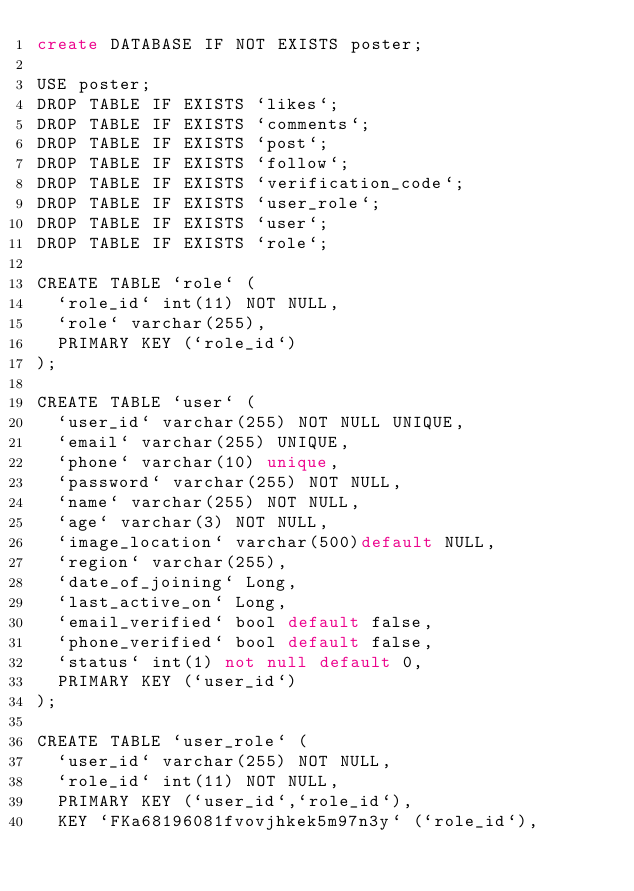<code> <loc_0><loc_0><loc_500><loc_500><_SQL_>create DATABASE IF NOT EXISTS poster;

USE poster;
DROP TABLE IF EXISTS `likes`;
DROP TABLE IF EXISTS `comments`;
DROP TABLE IF EXISTS `post`;
DROP TABLE IF EXISTS `follow`;
DROP TABLE IF EXISTS `verification_code`;
DROP TABLE IF EXISTS `user_role`;
DROP TABLE IF EXISTS `user`;
DROP TABLE IF EXISTS `role`;

CREATE TABLE `role` (
  `role_id` int(11) NOT NULL,
  `role` varchar(255),
  PRIMARY KEY (`role_id`)
);

CREATE TABLE `user` (
  `user_id` varchar(255) NOT NULL UNIQUE,
  `email` varchar(255) UNIQUE,
  `phone` varchar(10) unique,
  `password` varchar(255) NOT NULL,
  `name` varchar(255) NOT NULL,
  `age` varchar(3) NOT NULL,
  `image_location` varchar(500)default NULL,
  `region` varchar(255),
  `date_of_joining` Long,
  `last_active_on` Long,
  `email_verified` bool default false,
  `phone_verified` bool default false,
  `status` int(1) not null default 0,
  PRIMARY KEY (`user_id`)
);

CREATE TABLE `user_role` (
  `user_id` varchar(255) NOT NULL,
  `role_id` int(11) NOT NULL,
  PRIMARY KEY (`user_id`,`role_id`),
  KEY `FKa68196081fvovjhkek5m97n3y` (`role_id`),</code> 